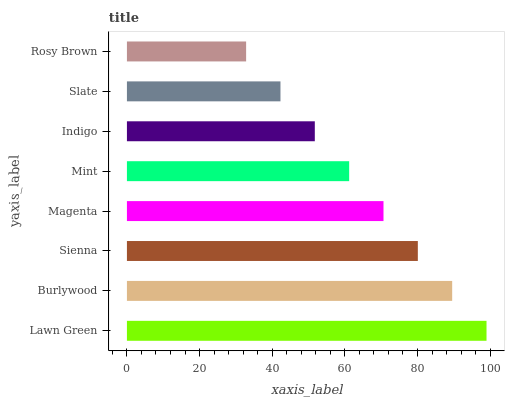Is Rosy Brown the minimum?
Answer yes or no. Yes. Is Lawn Green the maximum?
Answer yes or no. Yes. Is Burlywood the minimum?
Answer yes or no. No. Is Burlywood the maximum?
Answer yes or no. No. Is Lawn Green greater than Burlywood?
Answer yes or no. Yes. Is Burlywood less than Lawn Green?
Answer yes or no. Yes. Is Burlywood greater than Lawn Green?
Answer yes or no. No. Is Lawn Green less than Burlywood?
Answer yes or no. No. Is Magenta the high median?
Answer yes or no. Yes. Is Mint the low median?
Answer yes or no. Yes. Is Burlywood the high median?
Answer yes or no. No. Is Rosy Brown the low median?
Answer yes or no. No. 